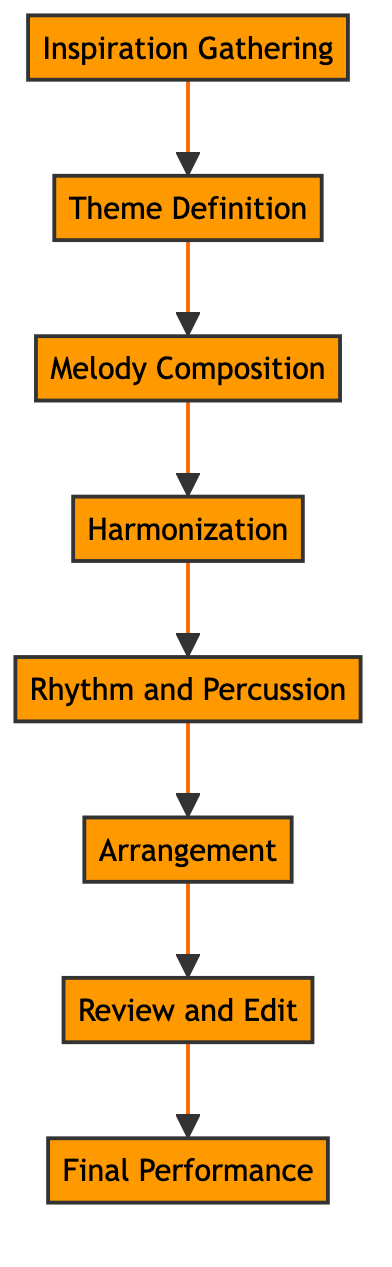What is the first step in the musical composition process? The first step in the process is "Inspiration Gathering," which is the starting point where musical ideas are collected.
Answer: Inspiration Gathering How many processes are in the diagram? The diagram contains eight processes that detail the steps in creating a new musical composition.
Answer: Eight What follows the "Theme Definition" process? The process that follows "Theme Definition" is "Melody Composition," which involves crafting the main melody connected to the established theme.
Answer: Melody Composition What is the last step before "Final Performance"? The last step before "Final Performance" is "Review and Edit," where the entire composition is reviewed and fine-tuned for coherence.
Answer: Review and Edit Which process integrates dynamics reflecting motorcycle racing? The process that integrates dynamic rhythms and percussions reflecting motorcycle racing is "Rhythm and Percussion."
Answer: Rhythm and Percussion Which step is directly connected to "Harmonization"? The step directly connected to "Harmonization" is "Melody Composition," indicating that harmonies are added after the main melody is created.
Answer: Melody Composition What is the theme inspiration mentioned in the diagram? The thematic inspirations mentioned for the composition include "Speed," "Adrenaline," and "Victory," highlighting elements related to motorcycle racing.
Answer: Speed, Adrenaline, Victory What type of relationships are represented in the diagram? The relationships represented in the diagram are sequential, showing a flow from one process to another in the musical composition journey.
Answer: Sequential 